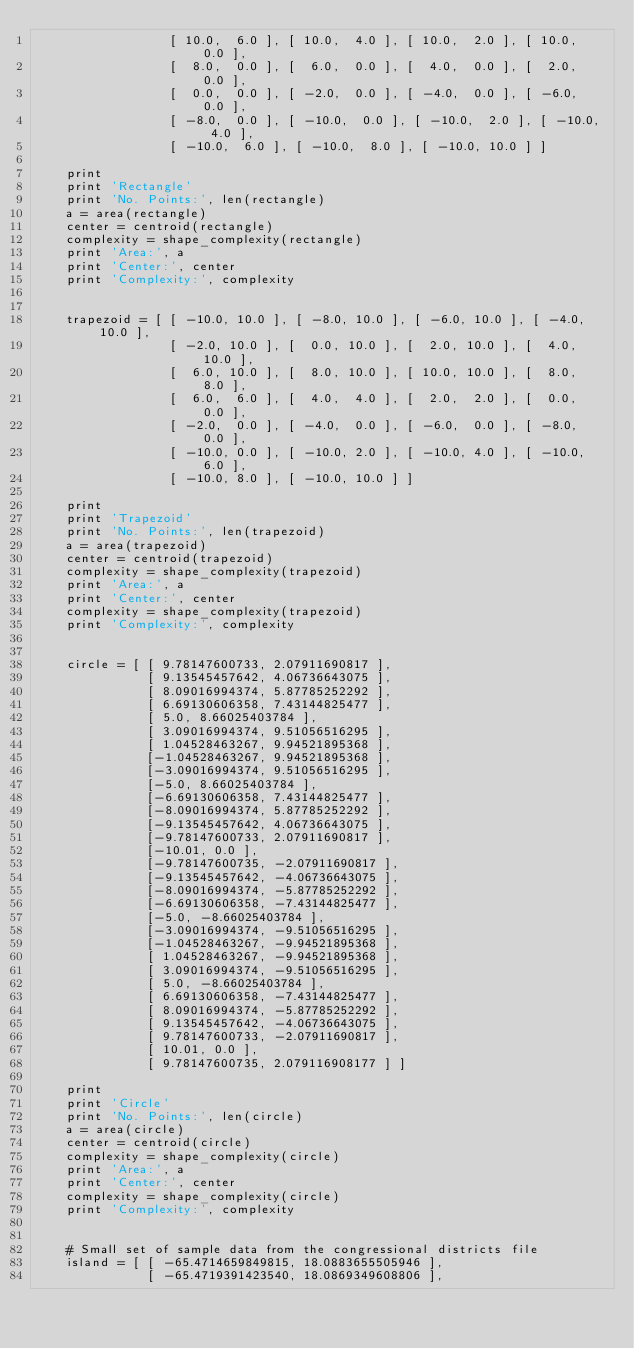Convert code to text. <code><loc_0><loc_0><loc_500><loc_500><_Python_>                  [ 10.0,  6.0 ], [ 10.0,  4.0 ], [ 10.0,  2.0 ], [ 10.0,  0.0 ],
                  [  8.0,  0.0 ], [  6.0,  0.0 ], [  4.0,  0.0 ], [  2.0,  0.0 ],
                  [  0.0,  0.0 ], [ -2.0,  0.0 ], [ -4.0,  0.0 ], [ -6.0,  0.0 ],
                  [ -8.0,  0.0 ], [ -10.0,  0.0 ], [ -10.0,  2.0 ], [ -10.0,  4.0 ],
                  [ -10.0,  6.0 ], [ -10.0,  8.0 ], [ -10.0, 10.0 ] ]

    print
    print 'Rectangle'
    print 'No. Points:', len(rectangle)
    a = area(rectangle)
    center = centroid(rectangle)
    complexity = shape_complexity(rectangle)
    print 'Area:', a
    print 'Center:', center
    print 'Complexity:', complexity


    trapezoid = [ [ -10.0, 10.0 ], [ -8.0, 10.0 ], [ -6.0, 10.0 ], [ -4.0, 10.0 ],
                  [ -2.0, 10.0 ], [  0.0, 10.0 ], [  2.0, 10.0 ], [  4.0, 10.0 ],
                  [  6.0, 10.0 ], [  8.0, 10.0 ], [ 10.0, 10.0 ], [  8.0,  8.0 ],
                  [  6.0,  6.0 ], [  4.0,  4.0 ], [  2.0,  2.0 ], [  0.0,  0.0 ],
                  [ -2.0,  0.0 ], [ -4.0,  0.0 ], [ -6.0,  0.0 ], [ -8.0,  0.0 ],
                  [ -10.0, 0.0 ], [ -10.0, 2.0 ], [ -10.0, 4.0 ], [ -10.0, 6.0 ],
                  [ -10.0, 8.0 ], [ -10.0, 10.0 ] ]

    print
    print 'Trapezoid'
    print 'No. Points:', len(trapezoid)
    a = area(trapezoid)
    center = centroid(trapezoid)
    complexity = shape_complexity(trapezoid)
    print 'Area:', a
    print 'Center:', center
    complexity = shape_complexity(trapezoid)
    print 'Complexity:', complexity


    circle = [ [ 9.78147600733, 2.07911690817 ],
               [ 9.13545457642, 4.06736643075 ],
               [ 8.09016994374, 5.87785252292 ],
               [ 6.69130606358, 7.43144825477 ],
               [ 5.0, 8.66025403784 ],
               [ 3.09016994374, 9.51056516295 ],
               [ 1.04528463267, 9.94521895368 ],
               [-1.04528463267, 9.94521895368 ],
               [-3.09016994374, 9.51056516295 ],
               [-5.0, 8.66025403784 ],
               [-6.69130606358, 7.43144825477 ],
               [-8.09016994374, 5.87785252292 ],
               [-9.13545457642, 4.06736643075 ],
               [-9.78147600733, 2.07911690817 ],
               [-10.01, 0.0 ],
               [-9.78147600735, -2.07911690817 ],
               [-9.13545457642, -4.06736643075 ],
               [-8.09016994374, -5.87785252292 ],
               [-6.69130606358, -7.43144825477 ],
               [-5.0, -8.66025403784 ],
               [-3.09016994374, -9.51056516295 ],
               [-1.04528463267, -9.94521895368 ],
               [ 1.04528463267, -9.94521895368 ],
               [ 3.09016994374, -9.51056516295 ],
               [ 5.0, -8.66025403784 ],
               [ 6.69130606358, -7.43144825477 ],
               [ 8.09016994374, -5.87785252292 ],
               [ 9.13545457642, -4.06736643075 ],
               [ 9.78147600733, -2.07911690817 ],
               [ 10.01, 0.0 ],
               [ 9.78147600735, 2.079116908177 ] ]
               
    print
    print 'Circle'
    print 'No. Points:', len(circle)
    a = area(circle)
    center = centroid(circle)
    complexity = shape_complexity(circle)
    print 'Area:', a
    print 'Center:', center
    complexity = shape_complexity(circle)
    print 'Complexity:', complexity


    # Small set of sample data from the congressional districts file
    island = [ [ -65.4714659849815, 18.0883655505946 ],
               [ -65.4719391423540, 18.0869349608806 ],</code> 